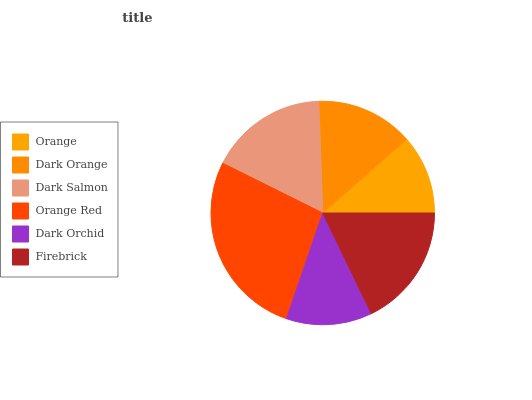Is Orange the minimum?
Answer yes or no. Yes. Is Orange Red the maximum?
Answer yes or no. Yes. Is Dark Orange the minimum?
Answer yes or no. No. Is Dark Orange the maximum?
Answer yes or no. No. Is Dark Orange greater than Orange?
Answer yes or no. Yes. Is Orange less than Dark Orange?
Answer yes or no. Yes. Is Orange greater than Dark Orange?
Answer yes or no. No. Is Dark Orange less than Orange?
Answer yes or no. No. Is Dark Salmon the high median?
Answer yes or no. Yes. Is Dark Orange the low median?
Answer yes or no. Yes. Is Dark Orange the high median?
Answer yes or no. No. Is Firebrick the low median?
Answer yes or no. No. 